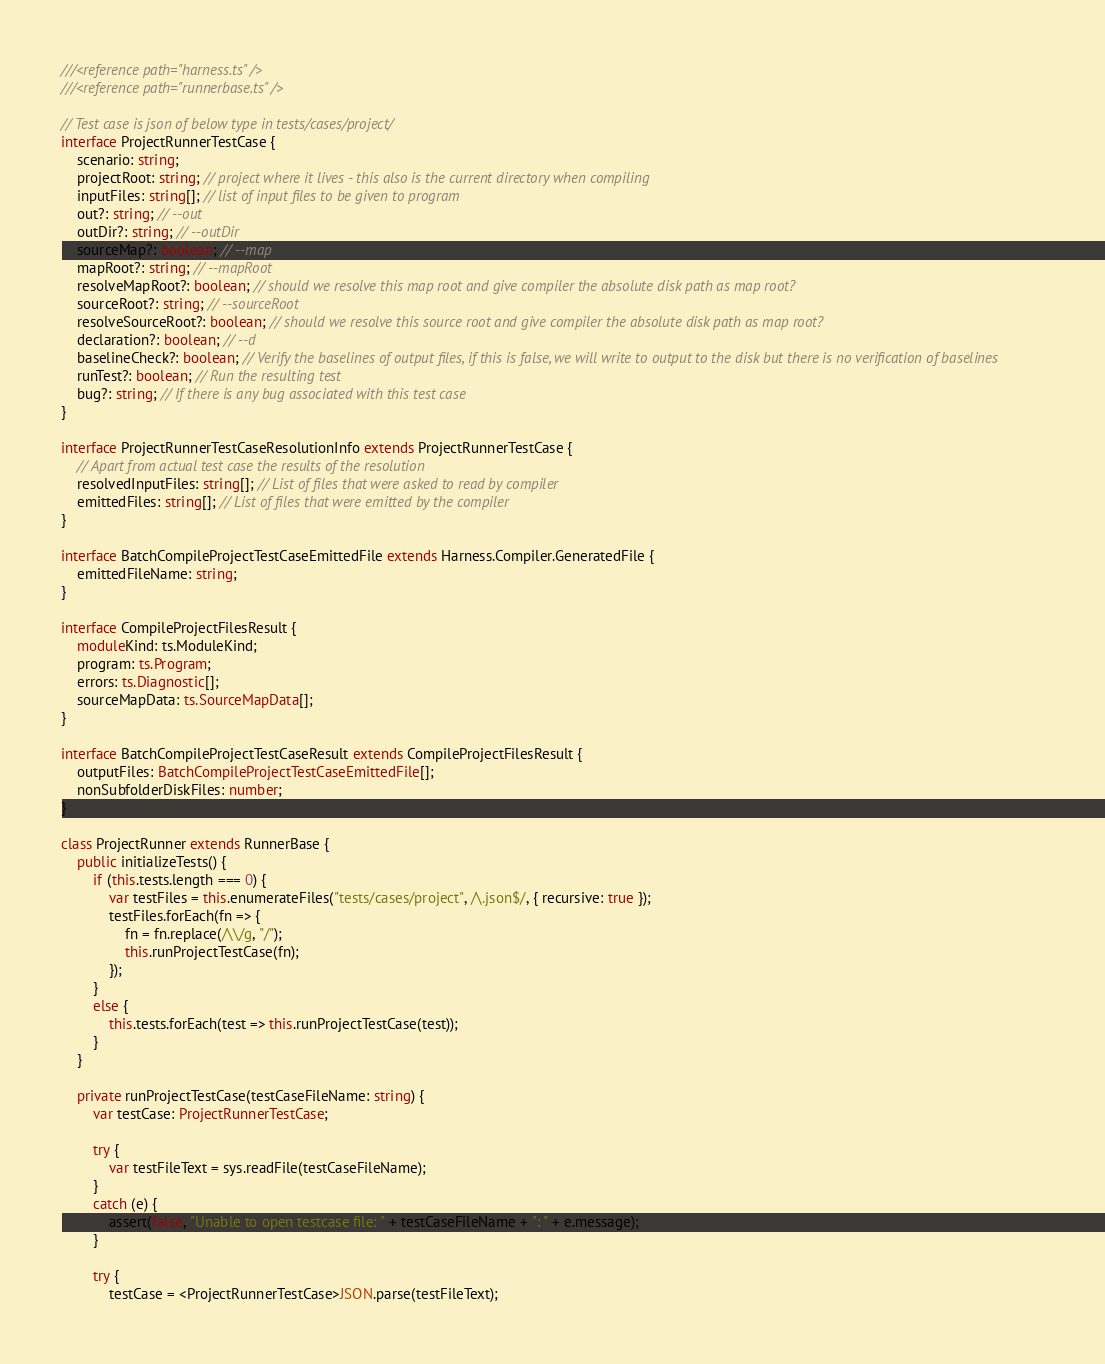Convert code to text. <code><loc_0><loc_0><loc_500><loc_500><_TypeScript_>///<reference path="harness.ts" />
///<reference path="runnerbase.ts" />

// Test case is json of below type in tests/cases/project/
interface ProjectRunnerTestCase {
    scenario: string;
    projectRoot: string; // project where it lives - this also is the current directory when compiling
    inputFiles: string[]; // list of input files to be given to program
    out?: string; // --out
    outDir?: string; // --outDir
    sourceMap?: boolean; // --map
    mapRoot?: string; // --mapRoot
    resolveMapRoot?: boolean; // should we resolve this map root and give compiler the absolute disk path as map root?
    sourceRoot?: string; // --sourceRoot
    resolveSourceRoot?: boolean; // should we resolve this source root and give compiler the absolute disk path as map root?
    declaration?: boolean; // --d
    baselineCheck?: boolean; // Verify the baselines of output files, if this is false, we will write to output to the disk but there is no verification of baselines
    runTest?: boolean; // Run the resulting test
    bug?: string; // If there is any bug associated with this test case
}

interface ProjectRunnerTestCaseResolutionInfo extends ProjectRunnerTestCase {
    // Apart from actual test case the results of the resolution
    resolvedInputFiles: string[]; // List of files that were asked to read by compiler
    emittedFiles: string[]; // List of files that were emitted by the compiler
}

interface BatchCompileProjectTestCaseEmittedFile extends Harness.Compiler.GeneratedFile {
    emittedFileName: string;
}

interface CompileProjectFilesResult {
    moduleKind: ts.ModuleKind;
    program: ts.Program;
    errors: ts.Diagnostic[];
    sourceMapData: ts.SourceMapData[];
}

interface BatchCompileProjectTestCaseResult extends CompileProjectFilesResult {
    outputFiles: BatchCompileProjectTestCaseEmittedFile[];
    nonSubfolderDiskFiles: number;
}

class ProjectRunner extends RunnerBase {
    public initializeTests() {
        if (this.tests.length === 0) {
            var testFiles = this.enumerateFiles("tests/cases/project", /\.json$/, { recursive: true });
            testFiles.forEach(fn => {
                fn = fn.replace(/\\/g, "/");
                this.runProjectTestCase(fn);
            });
        }
        else {
            this.tests.forEach(test => this.runProjectTestCase(test));
        }
    }

    private runProjectTestCase(testCaseFileName: string) {
        var testCase: ProjectRunnerTestCase;

        try {
            var testFileText = sys.readFile(testCaseFileName);
        }
        catch (e) {
            assert(false, "Unable to open testcase file: " + testCaseFileName + ": " + e.message);
        }

        try {
            testCase = <ProjectRunnerTestCase>JSON.parse(testFileText);</code> 